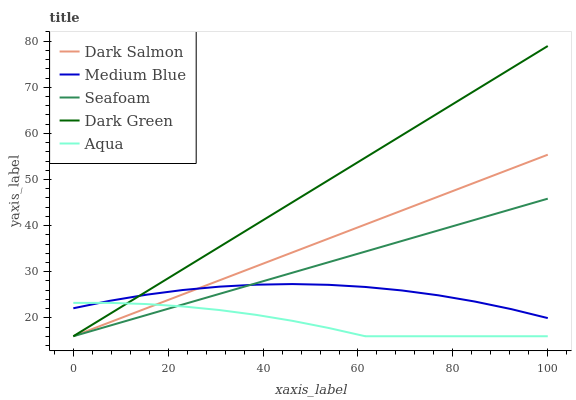Does Aqua have the minimum area under the curve?
Answer yes or no. Yes. Does Dark Green have the maximum area under the curve?
Answer yes or no. Yes. Does Medium Blue have the minimum area under the curve?
Answer yes or no. No. Does Medium Blue have the maximum area under the curve?
Answer yes or no. No. Is Seafoam the smoothest?
Answer yes or no. Yes. Is Aqua the roughest?
Answer yes or no. Yes. Is Dark Green the smoothest?
Answer yes or no. No. Is Dark Green the roughest?
Answer yes or no. No. Does Aqua have the lowest value?
Answer yes or no. Yes. Does Medium Blue have the lowest value?
Answer yes or no. No. Does Dark Green have the highest value?
Answer yes or no. Yes. Does Medium Blue have the highest value?
Answer yes or no. No. Does Aqua intersect Dark Salmon?
Answer yes or no. Yes. Is Aqua less than Dark Salmon?
Answer yes or no. No. Is Aqua greater than Dark Salmon?
Answer yes or no. No. 